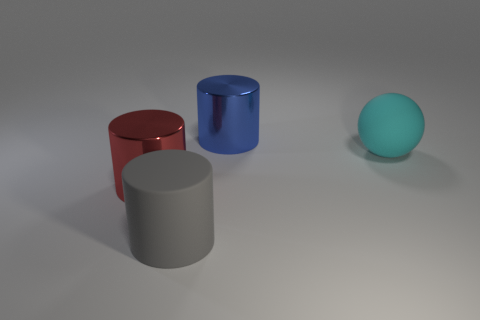Subtract all big rubber cylinders. How many cylinders are left? 2 Subtract 3 cylinders. How many cylinders are left? 0 Subtract all balls. How many objects are left? 3 Subtract all tiny yellow matte cubes. Subtract all big things. How many objects are left? 0 Add 4 big cyan balls. How many big cyan balls are left? 5 Add 2 large rubber balls. How many large rubber balls exist? 3 Add 1 small blue cylinders. How many objects exist? 5 Subtract all red cylinders. How many cylinders are left? 2 Subtract 0 purple cylinders. How many objects are left? 4 Subtract all purple spheres. Subtract all blue cylinders. How many spheres are left? 1 